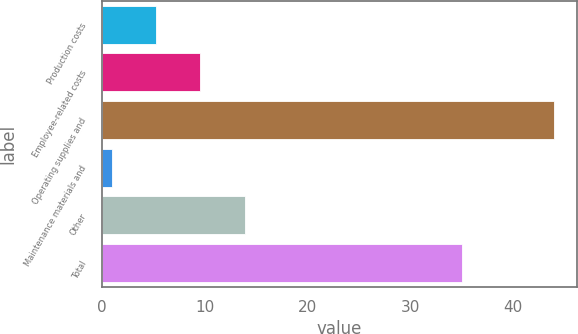Convert chart. <chart><loc_0><loc_0><loc_500><loc_500><bar_chart><fcel>Production costs<fcel>Employee-related costs<fcel>Operating supplies and<fcel>Maintenance materials and<fcel>Other<fcel>Total<nl><fcel>5.3<fcel>9.6<fcel>44<fcel>1<fcel>13.9<fcel>35<nl></chart> 